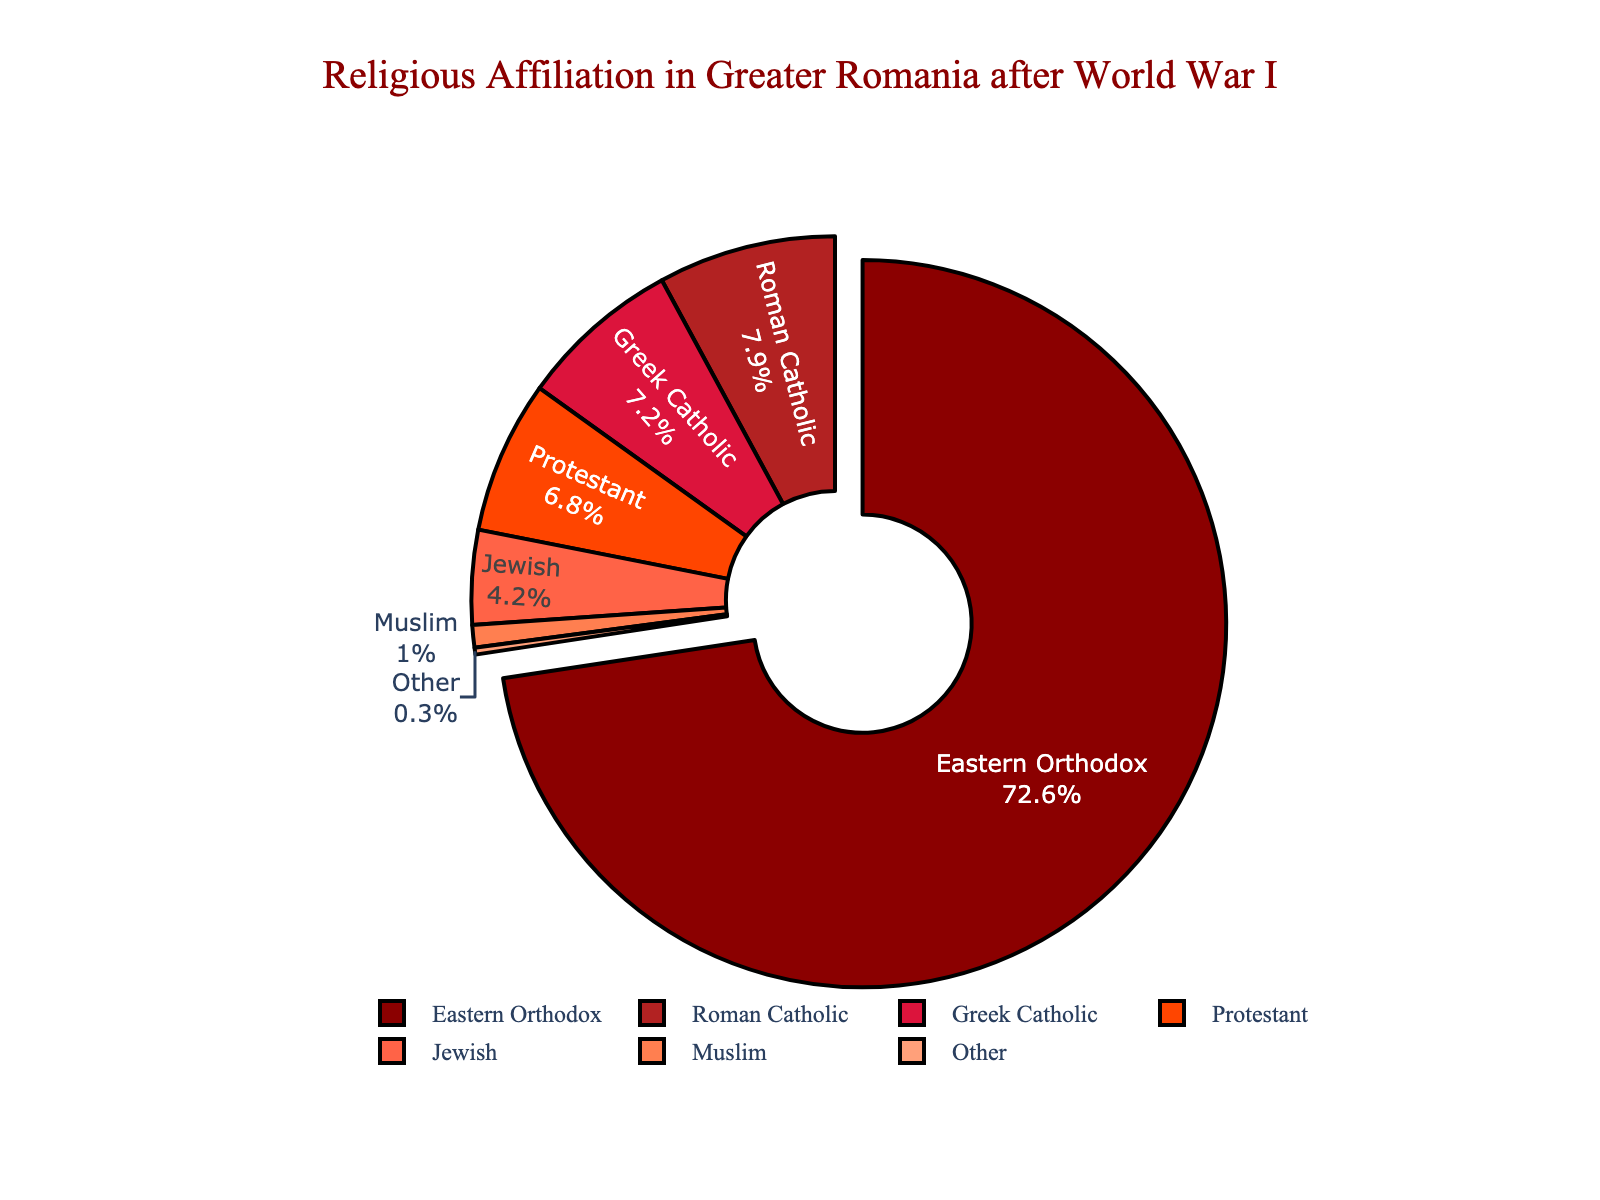What is the percentage of the largest religious group? The largest religious group in the pie chart is identified by the slice with the highest percentage. For Greater Romania after World War I, the largest group is Eastern Orthodox.
Answer: 72.6% Which religious affiliation is exactly 7.9%? To find the religious affiliation that corresponds to 7.9%, locate the slice with that percentage. The Roman Catholic group has a percentage of 7.9%.
Answer: Roman Catholic What is the combined percentage of Greek Catholic and Protestant? To determine the combined percentage, sum the percentages for Greek Catholic and Protestant. Greek Catholic is 7.2% and Protestant is 6.8%. So the combined percentage is 7.2% + 6.8% = 14.0%.
Answer: 14.0% Which two religious groups have a combined percentage that is more than 10% but less than 15%? Calculate all possible combinations of two groups to find those with combined percentages between 10% and 15%. The combination of Greek Catholic (7.2%) and Protestant (6.8%) sums to 14.0%, which fits this range.
Answer: Greek Catholic and Protestant Which religious group has a noticeably different visual attribute (like a distinct color) because it is the largest segment? The largest segment, Eastern Orthodox, is visually distinguished by being "pulled out" slightly from the rest of the pie chart.
Answer: Eastern Orthodox Compare the percentages of Jewish and Muslim. Which is higher and by how much? The percentage of the Jewish population is 4.2% and the percentage of the Muslim population is 1.0%. To find the difference, subtract the smaller percentage from the larger one: 4.2% - 1.0% = 3.2%.
Answer: Jewish by 3.2% What is the total percentage of the remaining religions if Eastern Orthodox is excluded? Subtract the percentage of Eastern Orthodox from 100% to find the remaining religions' total percentage: 100% - 72.6% = 27.4%.
Answer: 27.4% Are Roman Catholic and Greek Catholic totals more or less than Protestant and Jewish added together? First, add the percentages of Roman Catholic (7.9%) and Greek Catholic (7.2%): 7.9% + 7.2% = 15.1%. Then, add Protestant (6.8%) and Jewish (4.2%): 6.8% + 4.2% = 11.0%. Compare these sums: 15.1% is more than 11.0%.
Answer: More How does the "Other" category visually relate to the rest of the pie chart? The "Other" category, being only 0.3%, appears as a very small slice relative to the other segments and is the smallest segment on the pie chart.
Answer: Very small slice If you were to merge Roman Catholic and Greek Catholic into a single category, what would their new percentage be and how would it rank among the existing categories? Add Roman Catholic (7.9%) and Greek Catholic (7.2%) to get the new percentage: 7.9% + 7.2% = 15.1%. This new category would rank second after Eastern Orthodox (72.6%) but before Protestant (6.8%).
Answer: 15.1%, second 